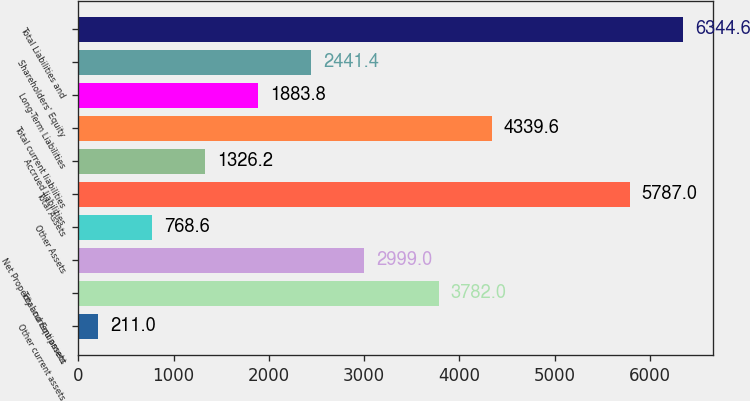Convert chart to OTSL. <chart><loc_0><loc_0><loc_500><loc_500><bar_chart><fcel>Other current assets<fcel>Total current assets<fcel>Net Property and Equipment<fcel>Other Assets<fcel>Total Assets<fcel>Accrued liabilities<fcel>Total current liabilities<fcel>Long-Term Liabilities<fcel>Shareholders' Equity<fcel>Total Liabilities and<nl><fcel>211<fcel>3782<fcel>2999<fcel>768.6<fcel>5787<fcel>1326.2<fcel>4339.6<fcel>1883.8<fcel>2441.4<fcel>6344.6<nl></chart> 